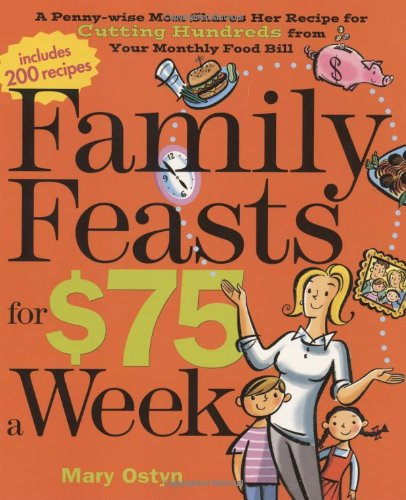Who is the author of this book? The author of 'Family Feasts for $75 a Week' is Mary Ostyn, who shares her extensive knowledge on managing a family's food budget effectively. 